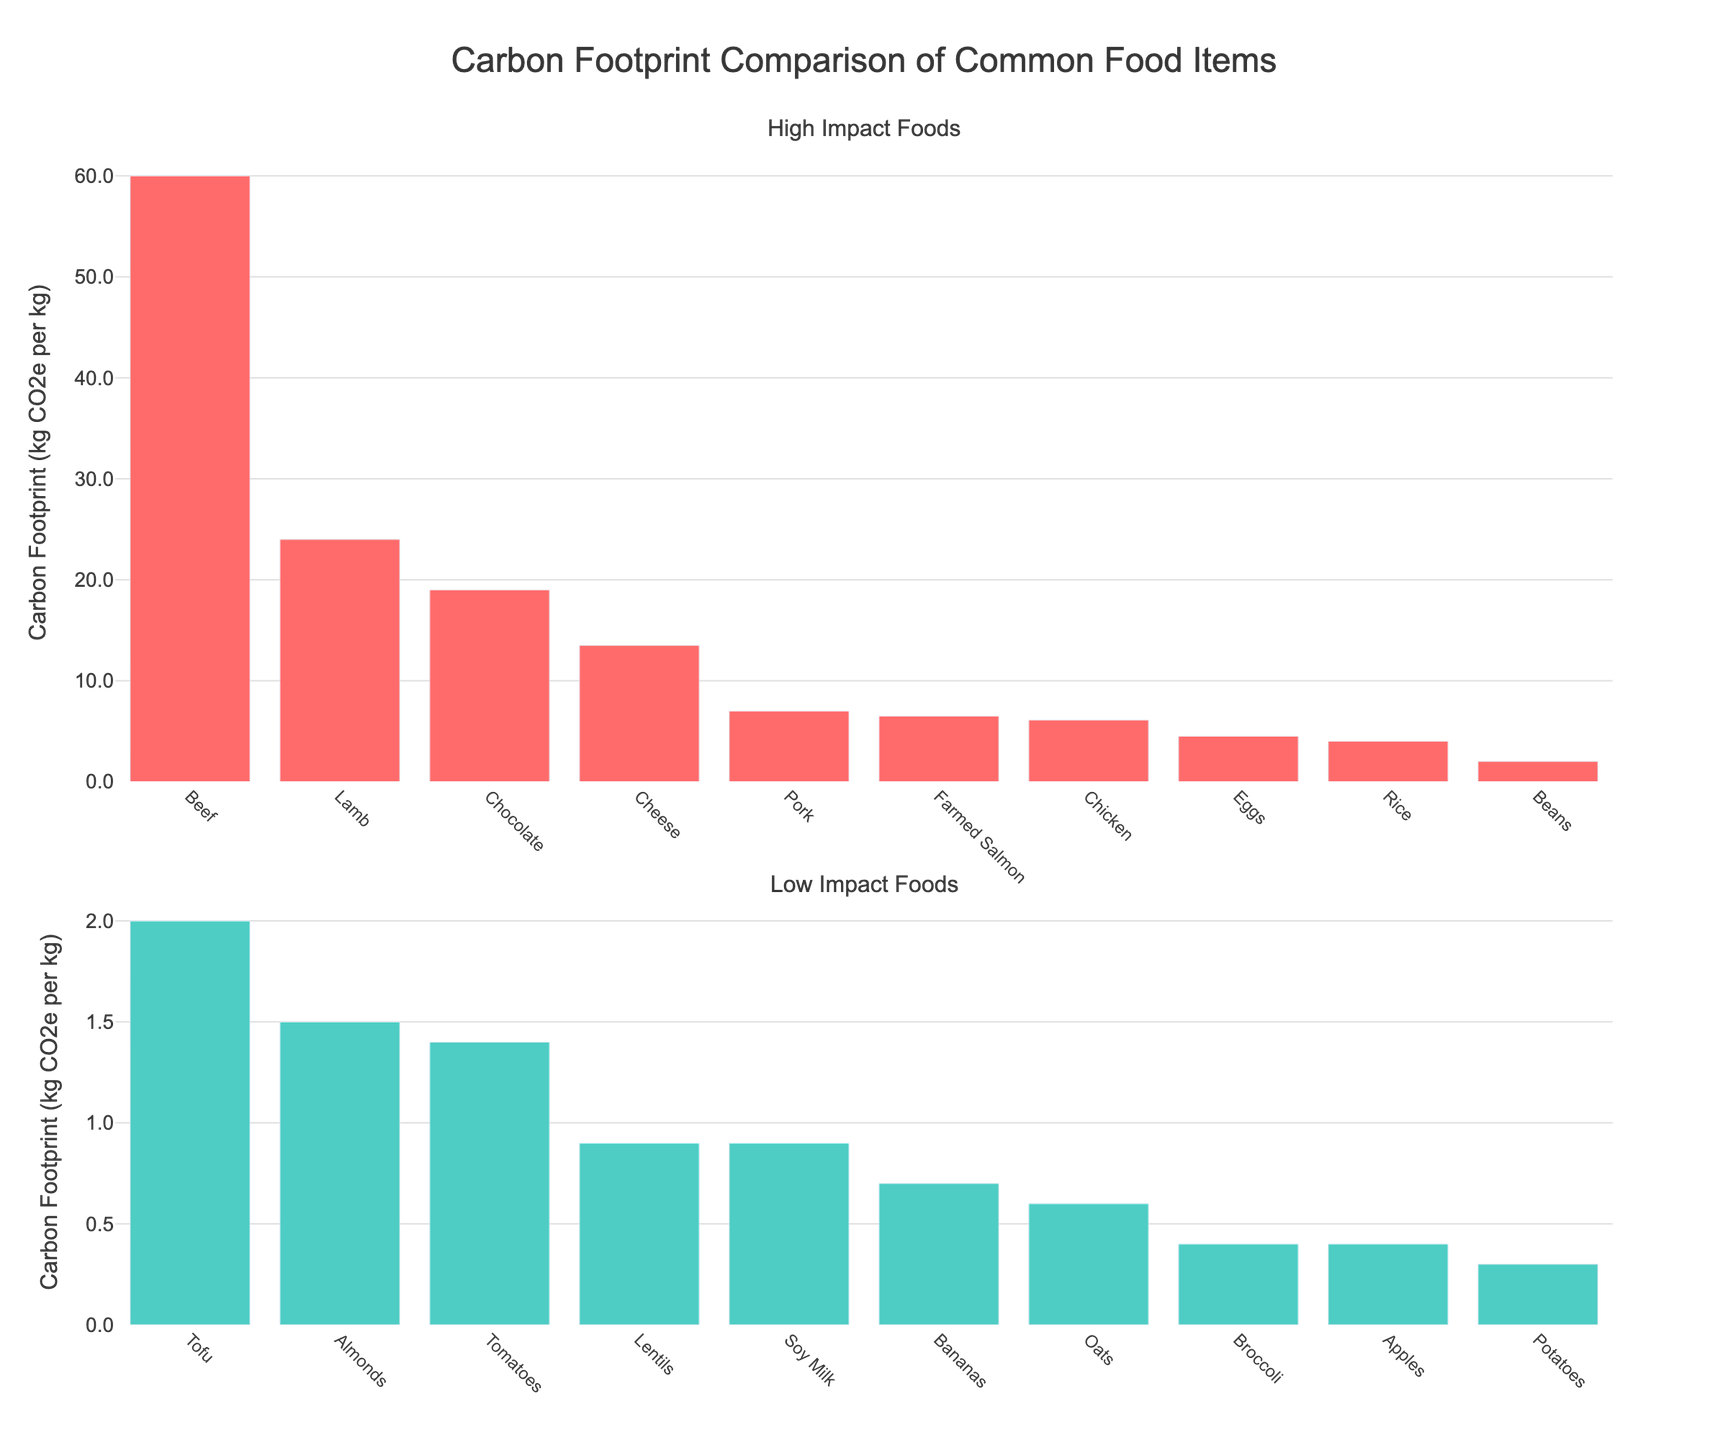Which food item has the highest carbon footprint? The food item with the highest carbon footprint is identified by the tallest bar in the top subplot under "High Impact Foods".
Answer: Beef Which food item has the lowest carbon footprint? The food item with the lowest carbon footprint is identified by the shortest bar in the bottom subplot under "Low Impact Foods".
Answer: Potatoes What is the combined carbon footprint of Beef, Lamb, and Cheese? Sum the carbon footprints of Beef (60 kg CO2e), Lamb (24 kg CO2e), and Cheese (13.5 kg CO2e). Therefore, 60 + 24 + 13.5 = 97.5 kg CO2e.
Answer: 97.5 kg CO2e How does the carbon footprint of Chicken compare to that of Pork? Check the heights of the bars for Chicken and Pork in the top subplot. Chicken has a carbon footprint of 6.1 kg CO2e while Pork has 7 kg CO2e.
Answer: Pork has a higher carbon footprint than Chicken Between Tofu and Farmed Salmon, which has a lower carbon footprint and by how much? Farmed Salmon has a carbon footprint of 6.5 kg CO2e, and Tofu has 2 kg CO2e. The difference is 6.5 - 2 = 4.5 kg CO2e.
Answer: Tofu, by 4.5 kg CO2e Which food item is categorized as high-impact with the lowest carbon footprint? Identify the lowest bar in the top subplot under "High Impact Foods". The lowest bar in this category represents Chicken with 6.1 kg CO2e.
Answer: Chicken What is the average carbon footprint of the low-impact foods listed? Calculate the sum of the carbon footprints of the food items listed in the bottom subplot and then divide by the number of items. The sum is 23.6 kg CO2e (total of all low-impact foods), divided by 10 items, resulting in an average of 23.6/10 = 2.36 kg CO2e.
Answer: 2.36 kg CO2e What is the difference between the carbon footprints of Chocolate and Eggs? The carbon footprint of Chocolate is 19 kg CO2e, and Eggs are 4.5 kg CO2e. The difference is 19 - 4.5 = 14.5 kg CO2e.
Answer: 14.5 kg CO2e Is the carbon footprint of Apples greater than or less than that of Broccoli? Compare the heights of the bars for Apples and Broccoli in the bottom subplot. Apples have a carbon footprint of 0.4 kg CO2e while Broccoli also has 0.4 kg CO2e.
Answer: Equal How many food items in the high-impact category have a carbon footprint greater than 10 kg CO2e? Count the number of food items in the top subplot that have a carbon footprint exceeding 10 kg CO2e. These food items are Beef, Lamb, Cheese, and Chocolate, totaling four items.
Answer: 4 